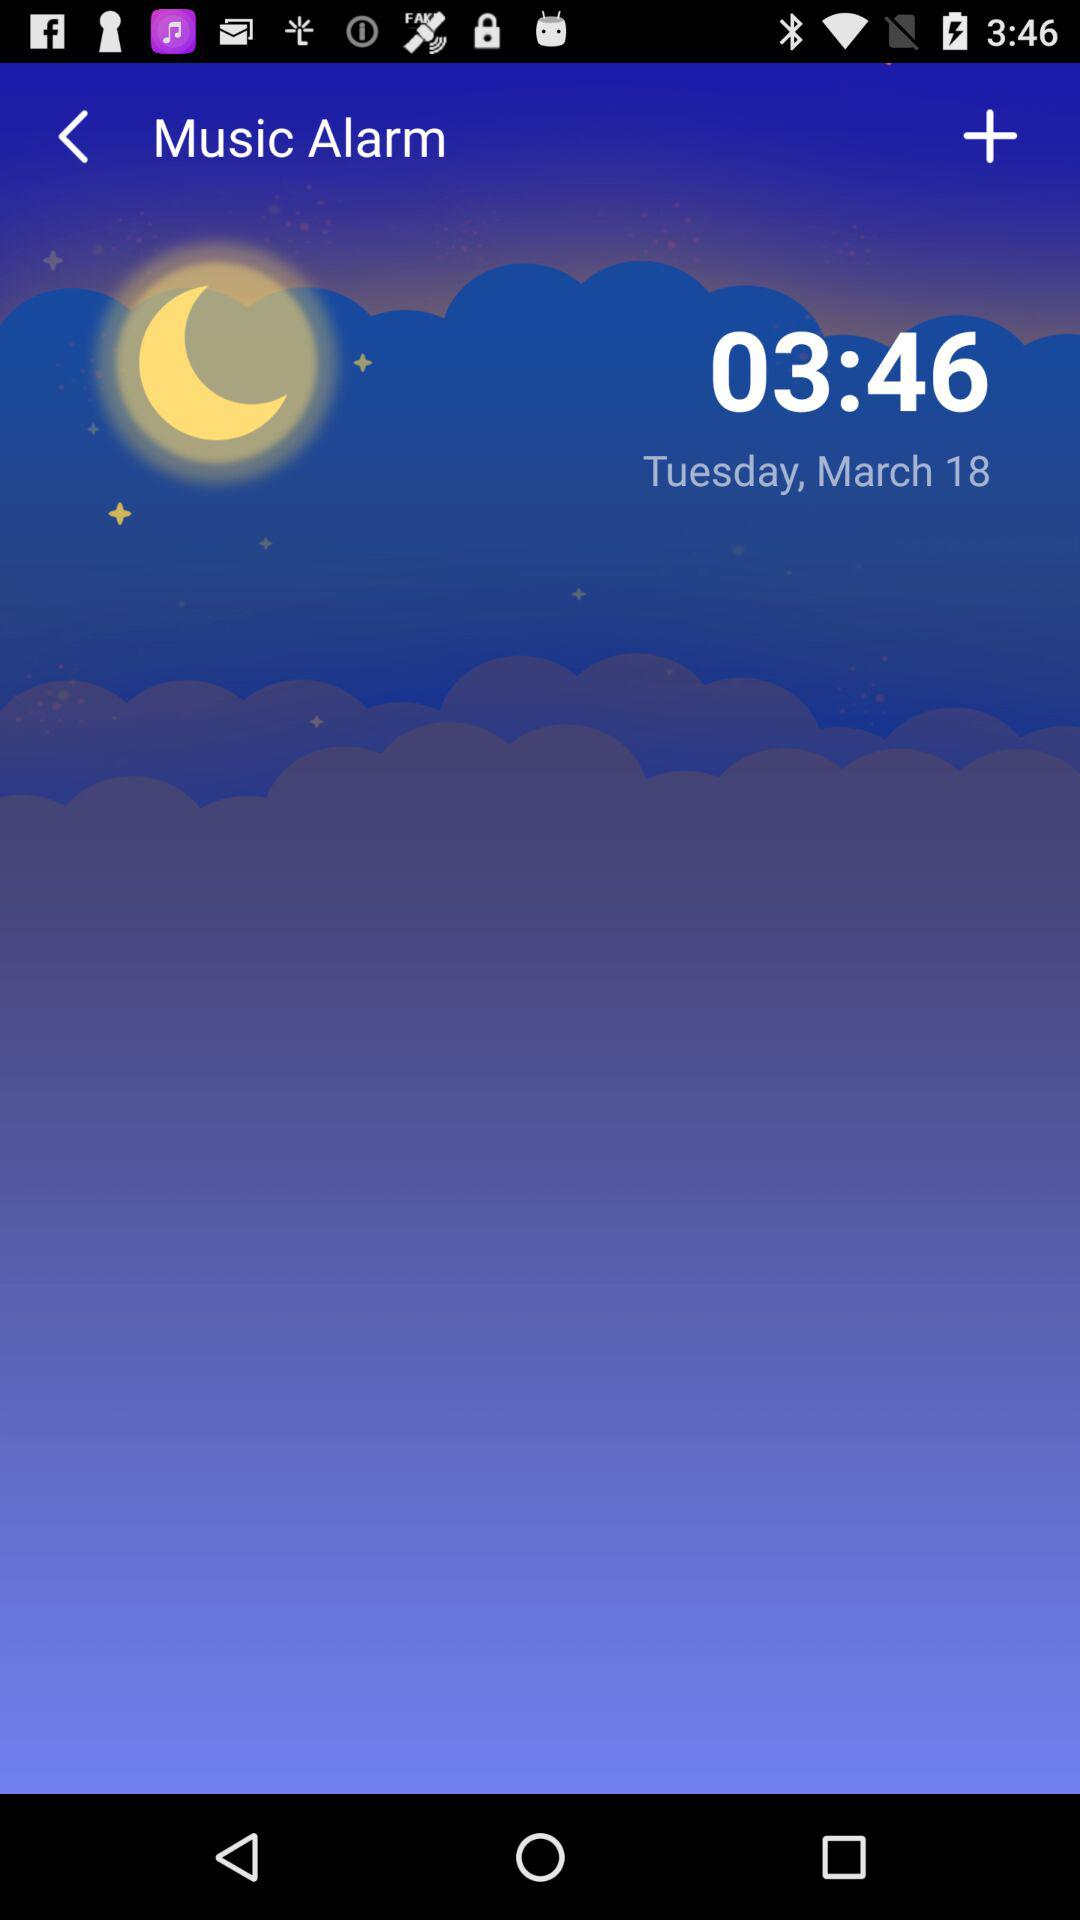What is the date? The date is Tuesday, March 18. 